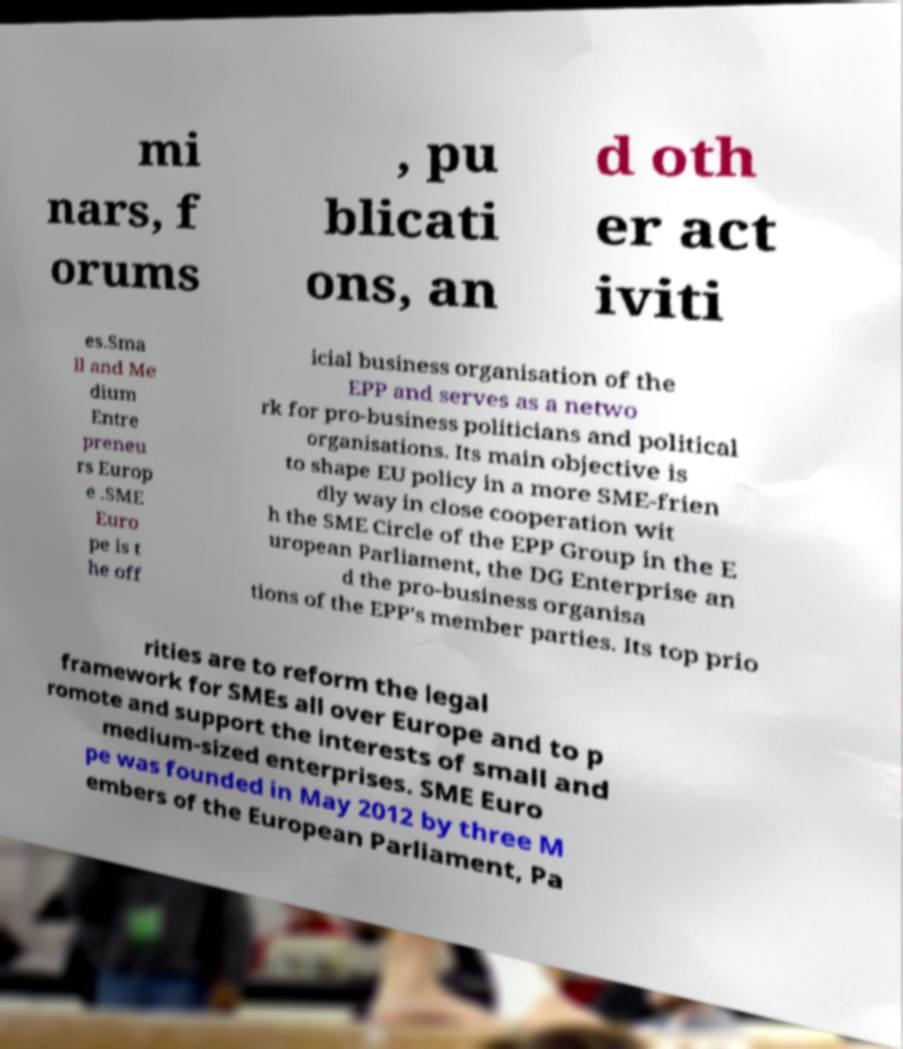Can you read and provide the text displayed in the image?This photo seems to have some interesting text. Can you extract and type it out for me? mi nars, f orums , pu blicati ons, an d oth er act iviti es.Sma ll and Me dium Entre preneu rs Europ e .SME Euro pe is t he off icial business organisation of the EPP and serves as a netwo rk for pro-business politicians and political organisations. Its main objective is to shape EU policy in a more SME-frien dly way in close cooperation wit h the SME Circle of the EPP Group in the E uropean Parliament, the DG Enterprise an d the pro-business organisa tions of the EPP's member parties. Its top prio rities are to reform the legal framework for SMEs all over Europe and to p romote and support the interests of small and medium-sized enterprises. SME Euro pe was founded in May 2012 by three M embers of the European Parliament, Pa 